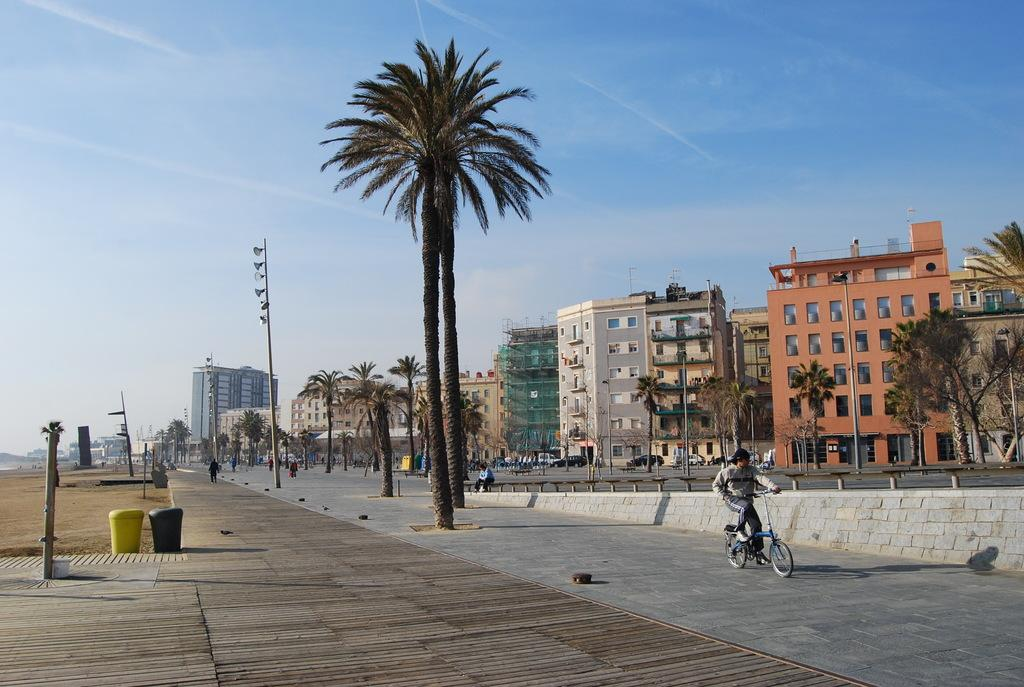What type of structures can be seen in the image? There are buildings with windows in the image. What natural elements are present in the image? There are trees in the image. What man-made objects can be seen in the image? There are vehicles in the image. Are there any living beings in the image? Yes, there are people in the image. What type of terrain is visible in the image? There is sand in the image. What other objects can be seen in the image? There are poles and a dustbin in the image. What can be seen in the background of the image? The sky is visible in the background of the image. Can you tell me how many spiders are crawling on the fruit in the image? There is no fruit or spiders present in the image. How does the person in the image help the spider with its web? There are no spiders or webs in the image, and the person is not shown helping any spiders. 